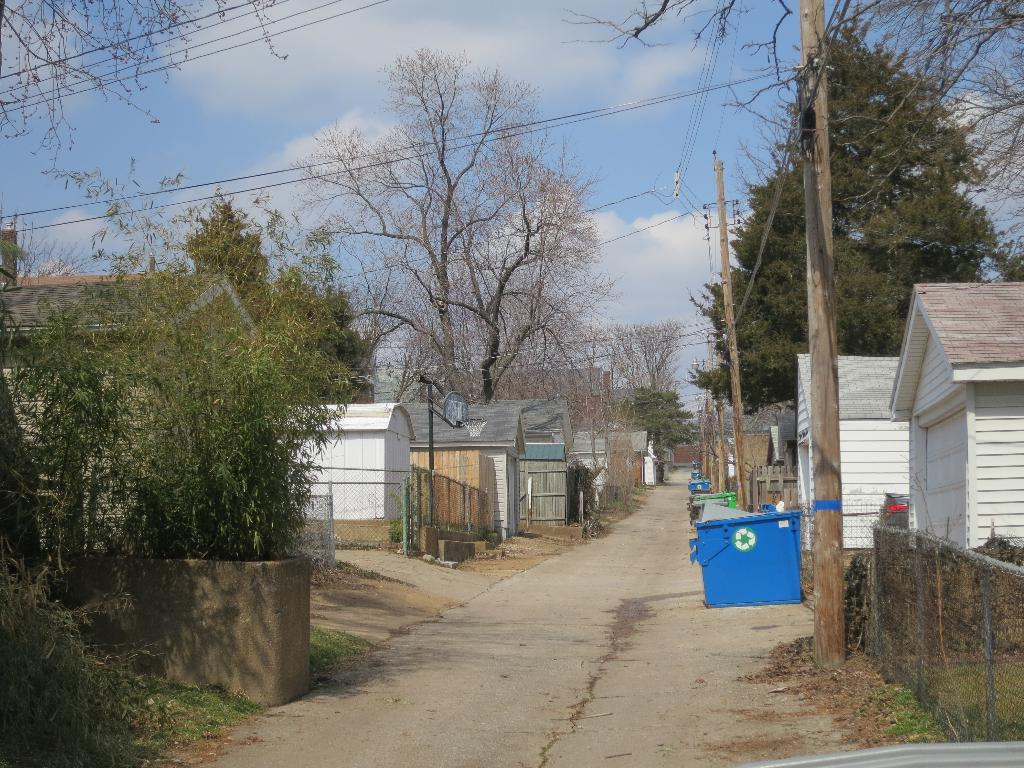What type of vegetation can be seen in the image? There are trees in the image. What is the color of the trees? The trees are green in color. What structures are visible in the background of the image? There are houses and electric poles in the background of the image. What is the color of the sky in the image? The sky is blue and white in color. What type of toothbrush is being used to clean the destruction in the image? There is no toothbrush or destruction present in the image. What type of power is being generated by the trees in the image? The trees in the image are not generating any power; they are simply vegetation. 